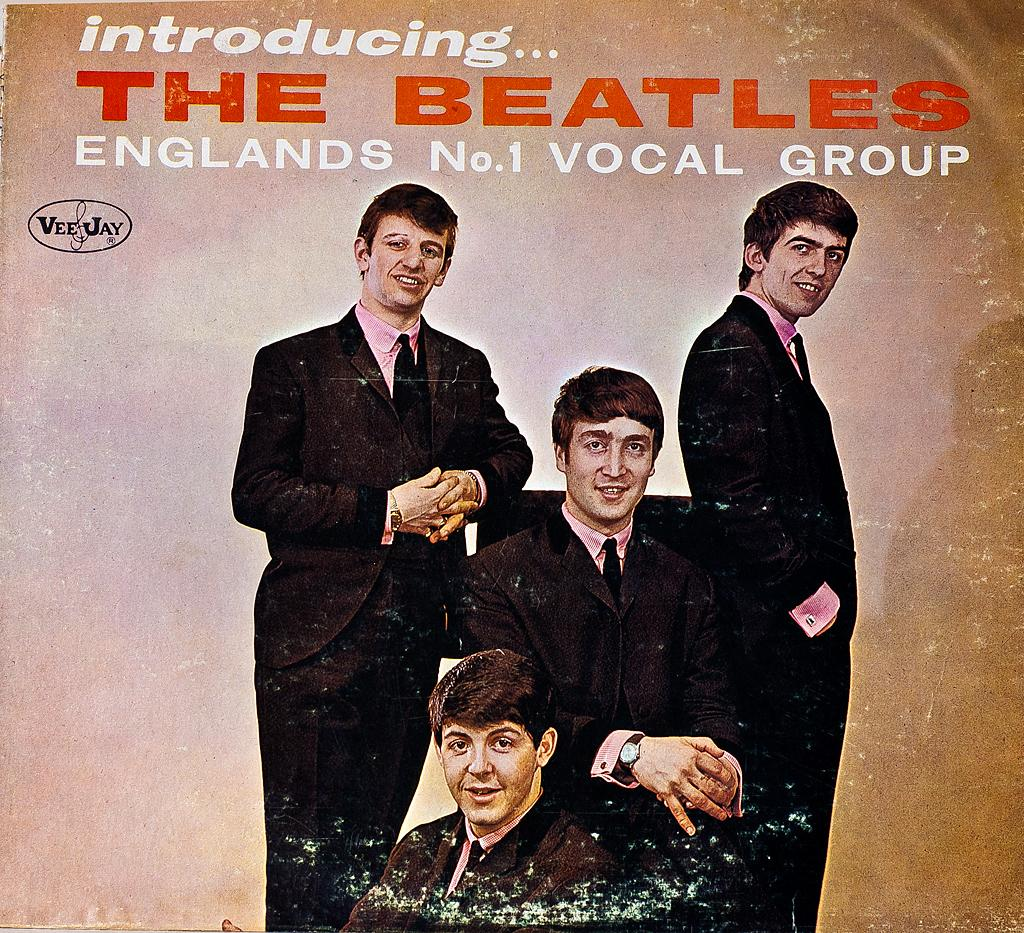What type of visual content is the image? The image is a poster. How many people are depicted in the poster? There are four people in the image. What are the people in the poster doing? The people are watching and smiling. Is there a specific position for one of the people in the poster? Yes, one person is sitting on a chair. What can be found at the top of the poster? There is text at the top of the image. What type of jeans is the robin wearing in the image? There is no robin or jeans present in the image; it features a poster with four people watching and smiling. 